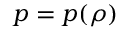<formula> <loc_0><loc_0><loc_500><loc_500>p = p ( \rho )</formula> 